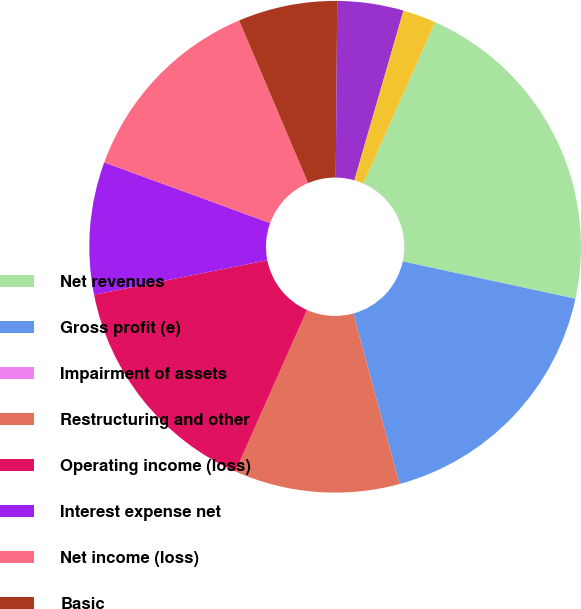<chart> <loc_0><loc_0><loc_500><loc_500><pie_chart><fcel>Net revenues<fcel>Gross profit (e)<fcel>Impairment of assets<fcel>Restructuring and other<fcel>Operating income (loss)<fcel>Interest expense net<fcel>Net income (loss)<fcel>Basic<fcel>Diluted<fcel>Dividends declared per common<nl><fcel>21.73%<fcel>17.39%<fcel>0.0%<fcel>10.87%<fcel>15.22%<fcel>8.7%<fcel>13.04%<fcel>6.52%<fcel>4.35%<fcel>2.18%<nl></chart> 